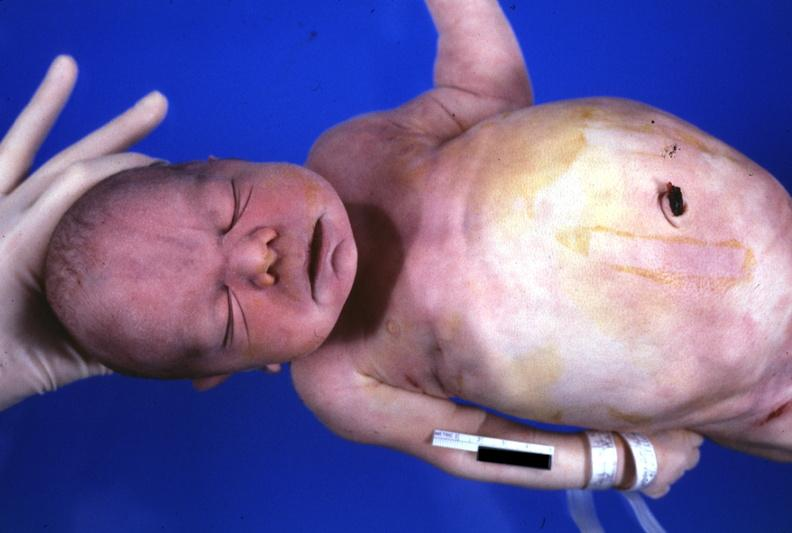s potters facies present?
Answer the question using a single word or phrase. Yes 